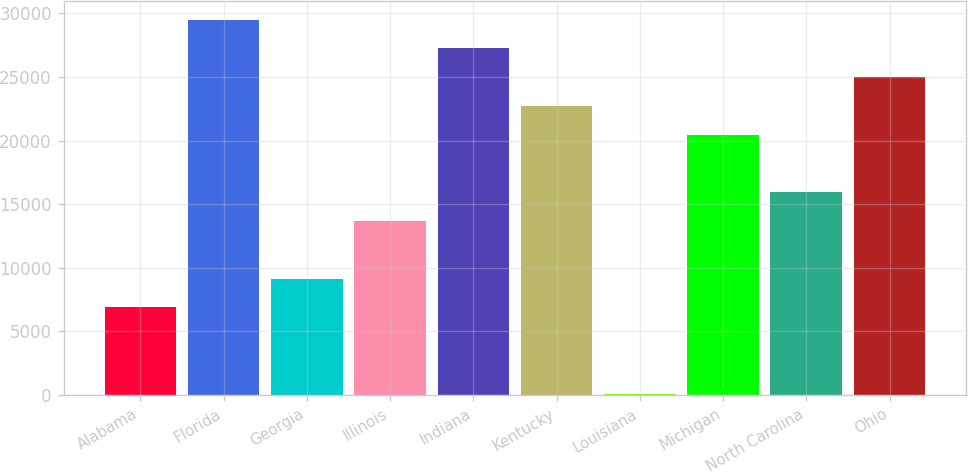<chart> <loc_0><loc_0><loc_500><loc_500><bar_chart><fcel>Alabama<fcel>Florida<fcel>Georgia<fcel>Illinois<fcel>Indiana<fcel>Kentucky<fcel>Louisiana<fcel>Michigan<fcel>North Carolina<fcel>Ohio<nl><fcel>6884.5<fcel>29509.5<fcel>9147<fcel>13672<fcel>27247<fcel>22722<fcel>97<fcel>20459.5<fcel>15934.5<fcel>24984.5<nl></chart> 